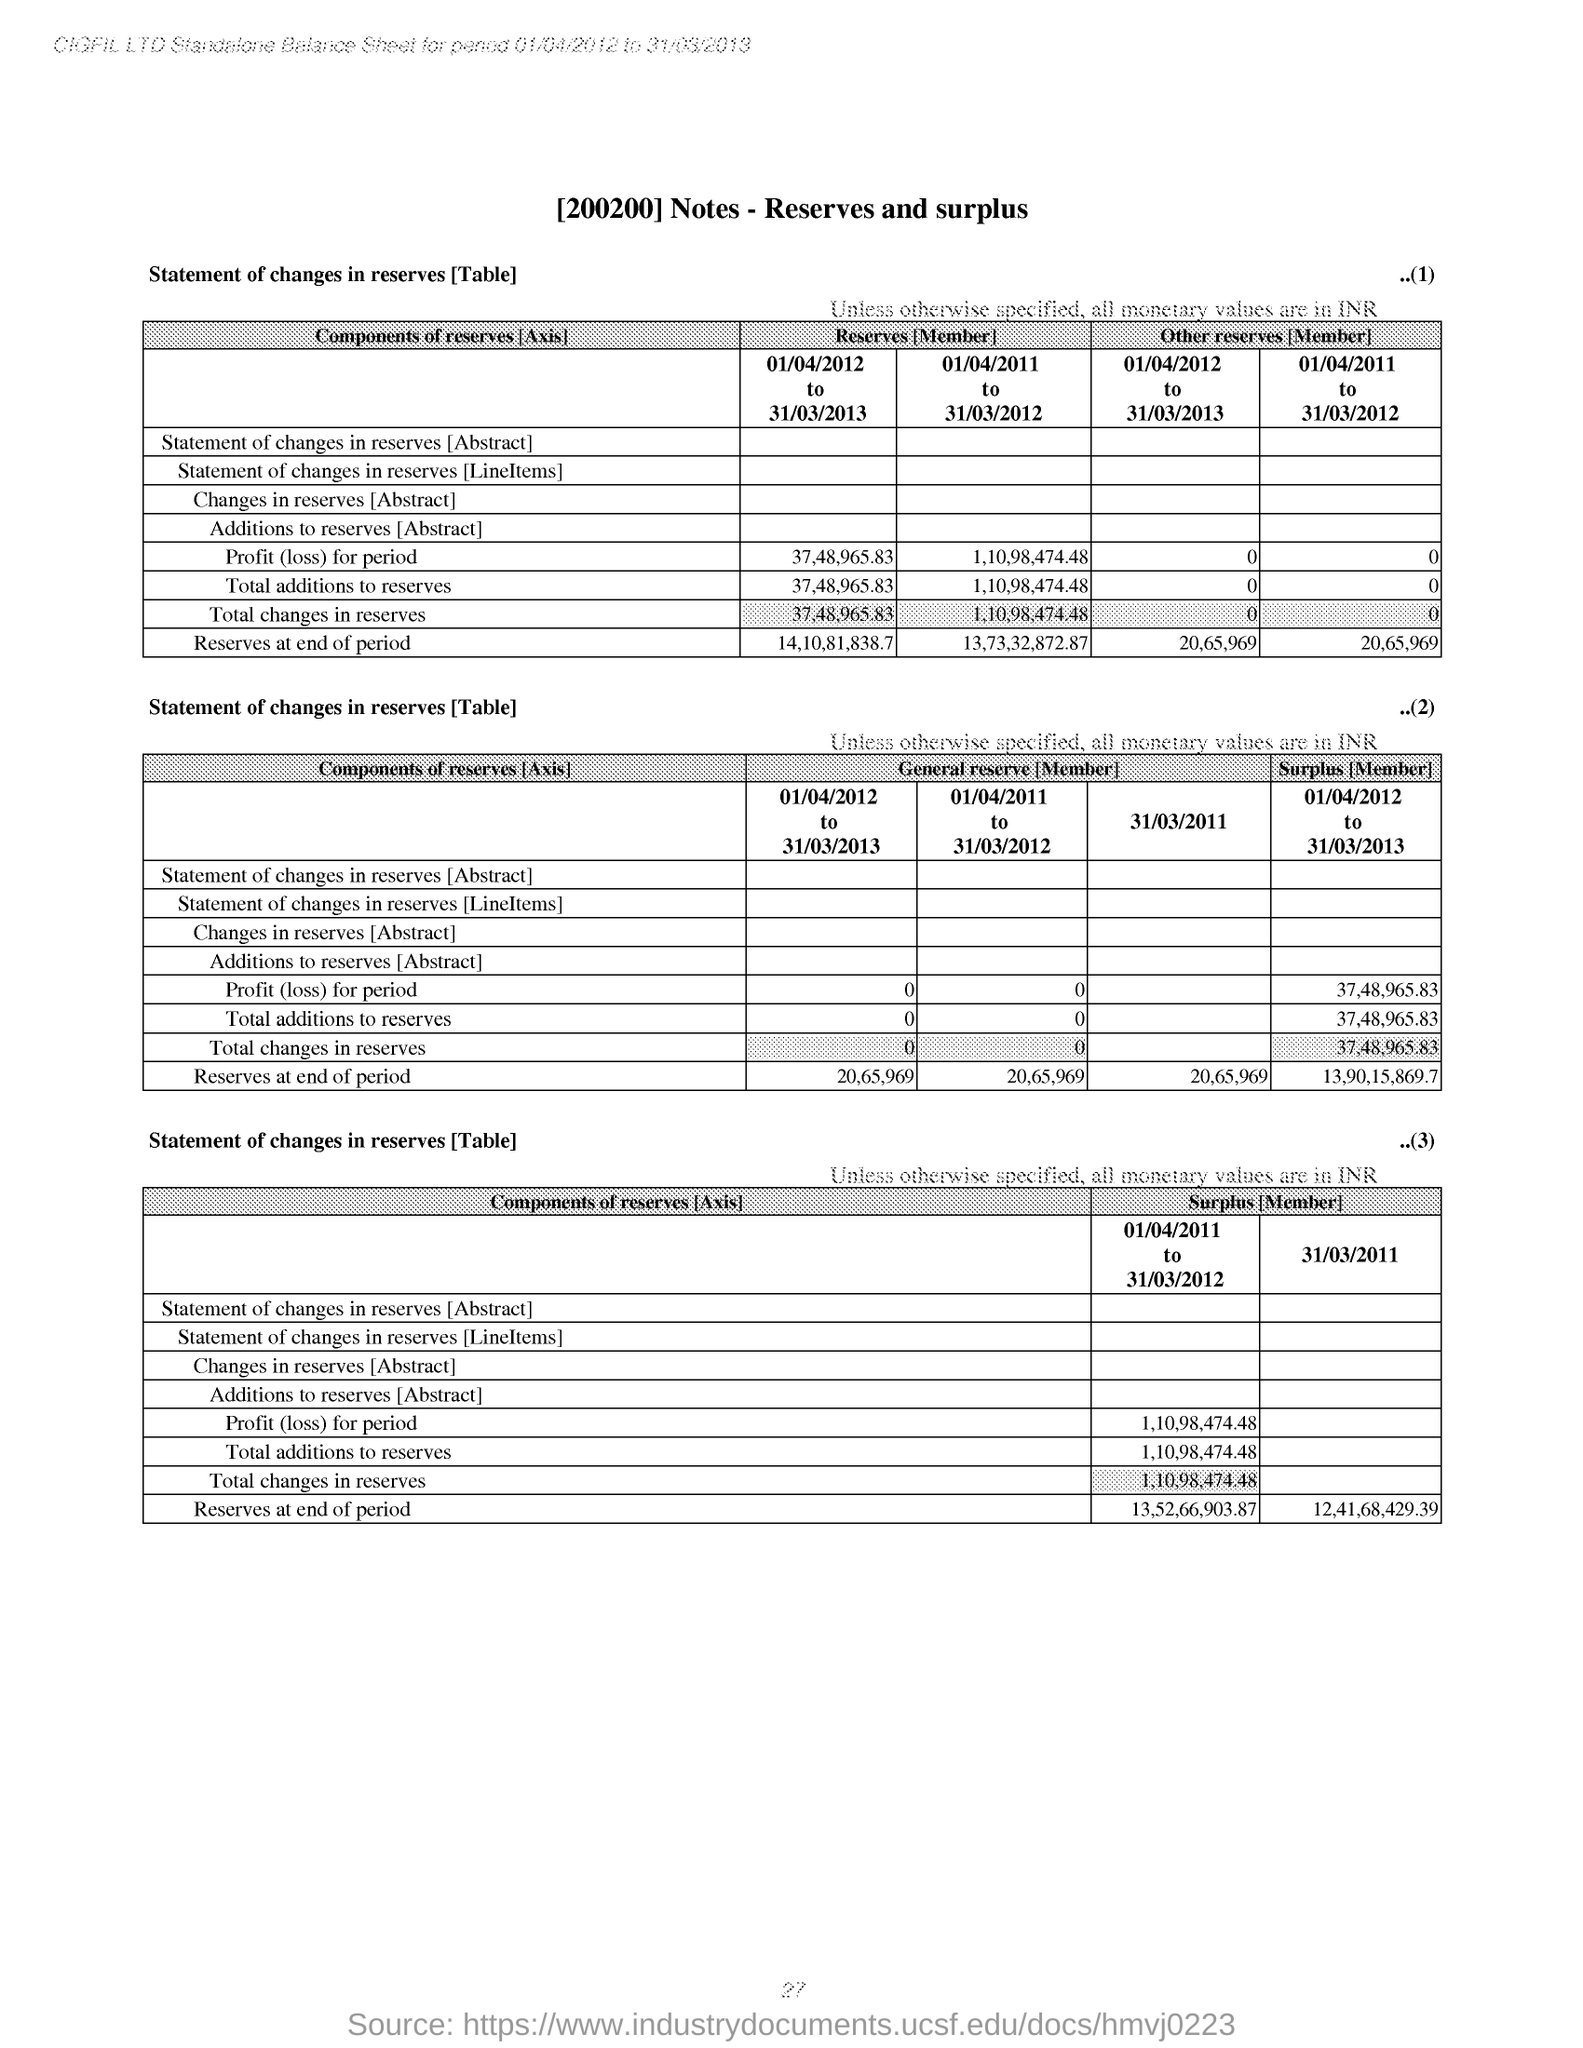What is the title of the document?
Your answer should be very brief. [200200] Notes - Reserves and surplus. What is the company name specified in the header of the document?
Your answer should be compact. CIGFIL LTD. How much is the 'Reserves at the end of period' 01/04/2012 to 31/03/2013 under column 'Reserves [Member] of table 1
Provide a succinct answer. 14,10,81,838.7. How much is the Total changes in reserves for the period 01/04/2011 to 31/03/2012 under column 'Surplus [Member] of last table?
Make the answer very short. 1,10,98,474.48. 